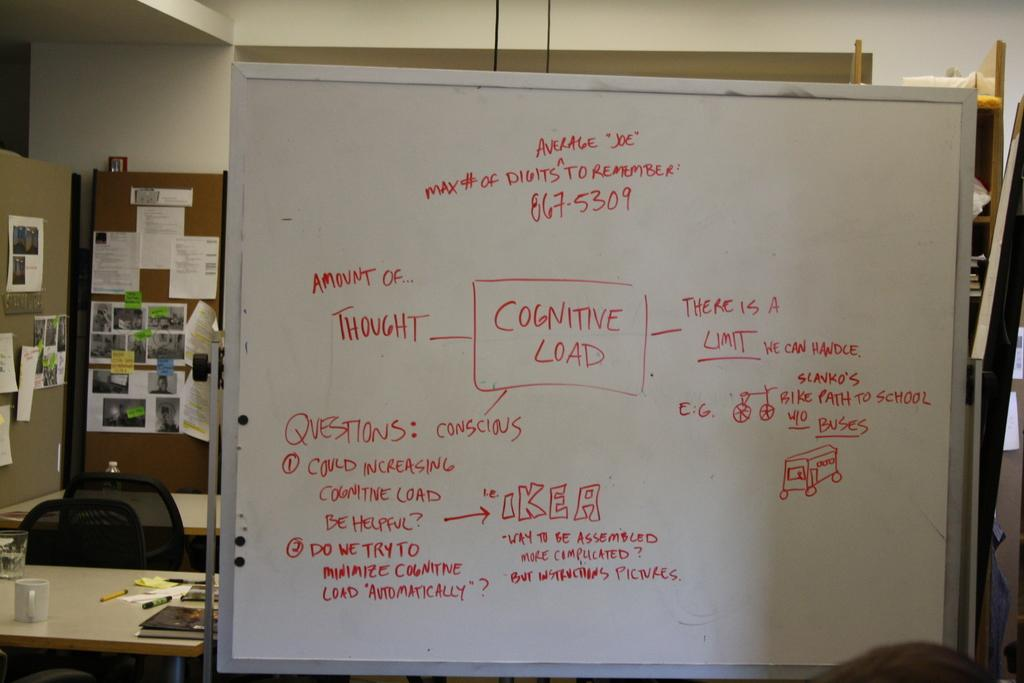<image>
Summarize the visual content of the image. A white board with Cognitive Load written on it 